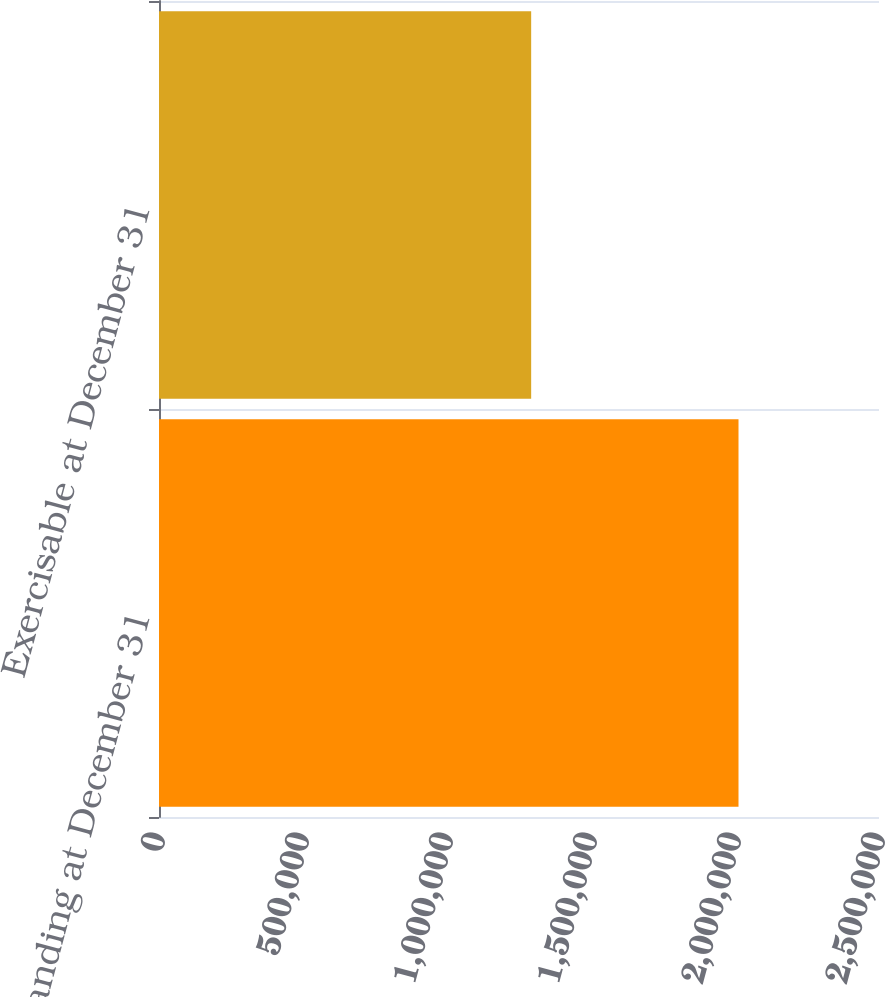Convert chart. <chart><loc_0><loc_0><loc_500><loc_500><bar_chart><fcel>Outstanding at December 31<fcel>Exercisable at December 31<nl><fcel>2.01216e+06<fcel>1.29225e+06<nl></chart> 